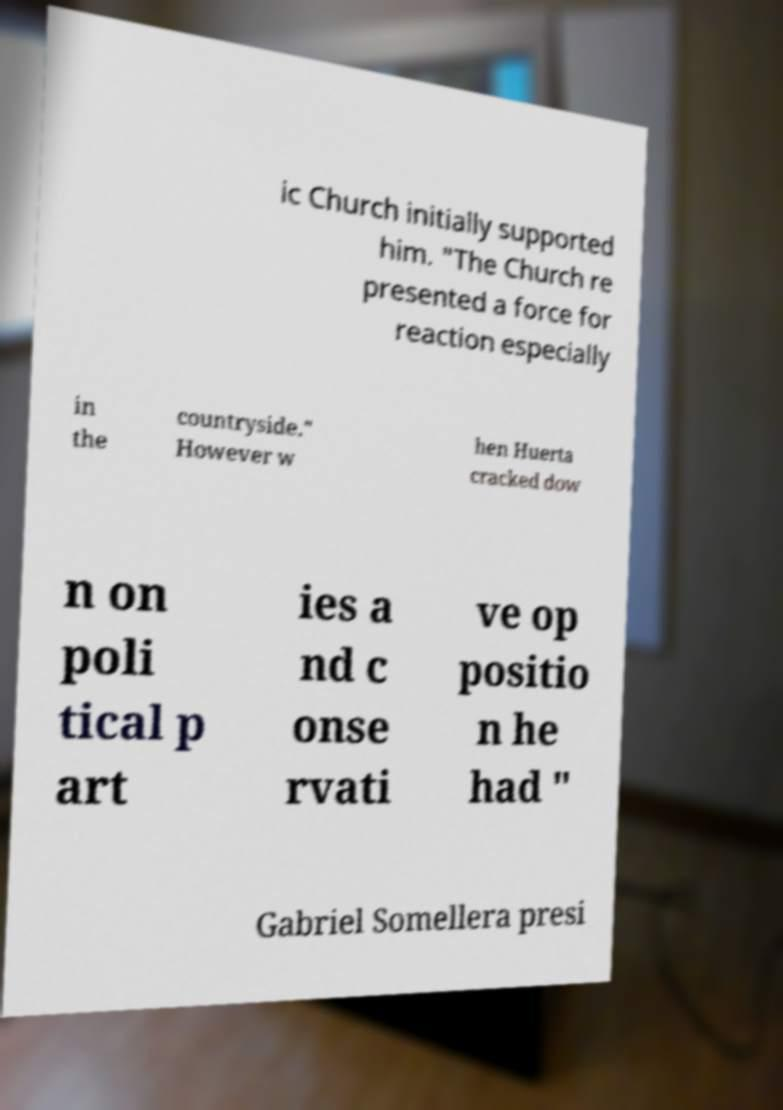Please read and relay the text visible in this image. What does it say? ic Church initially supported him. "The Church re presented a force for reaction especially in the countryside." However w hen Huerta cracked dow n on poli tical p art ies a nd c onse rvati ve op positio n he had " Gabriel Somellera presi 